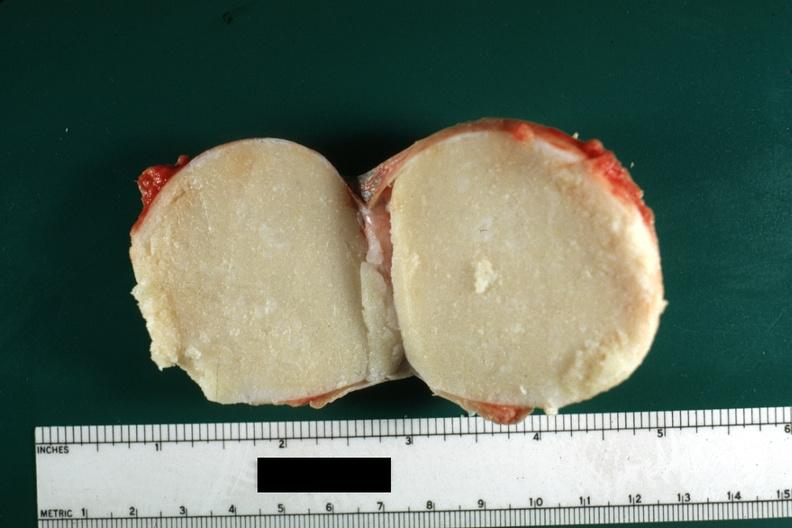s hilar cell tumor present?
Answer the question using a single word or phrase. No 